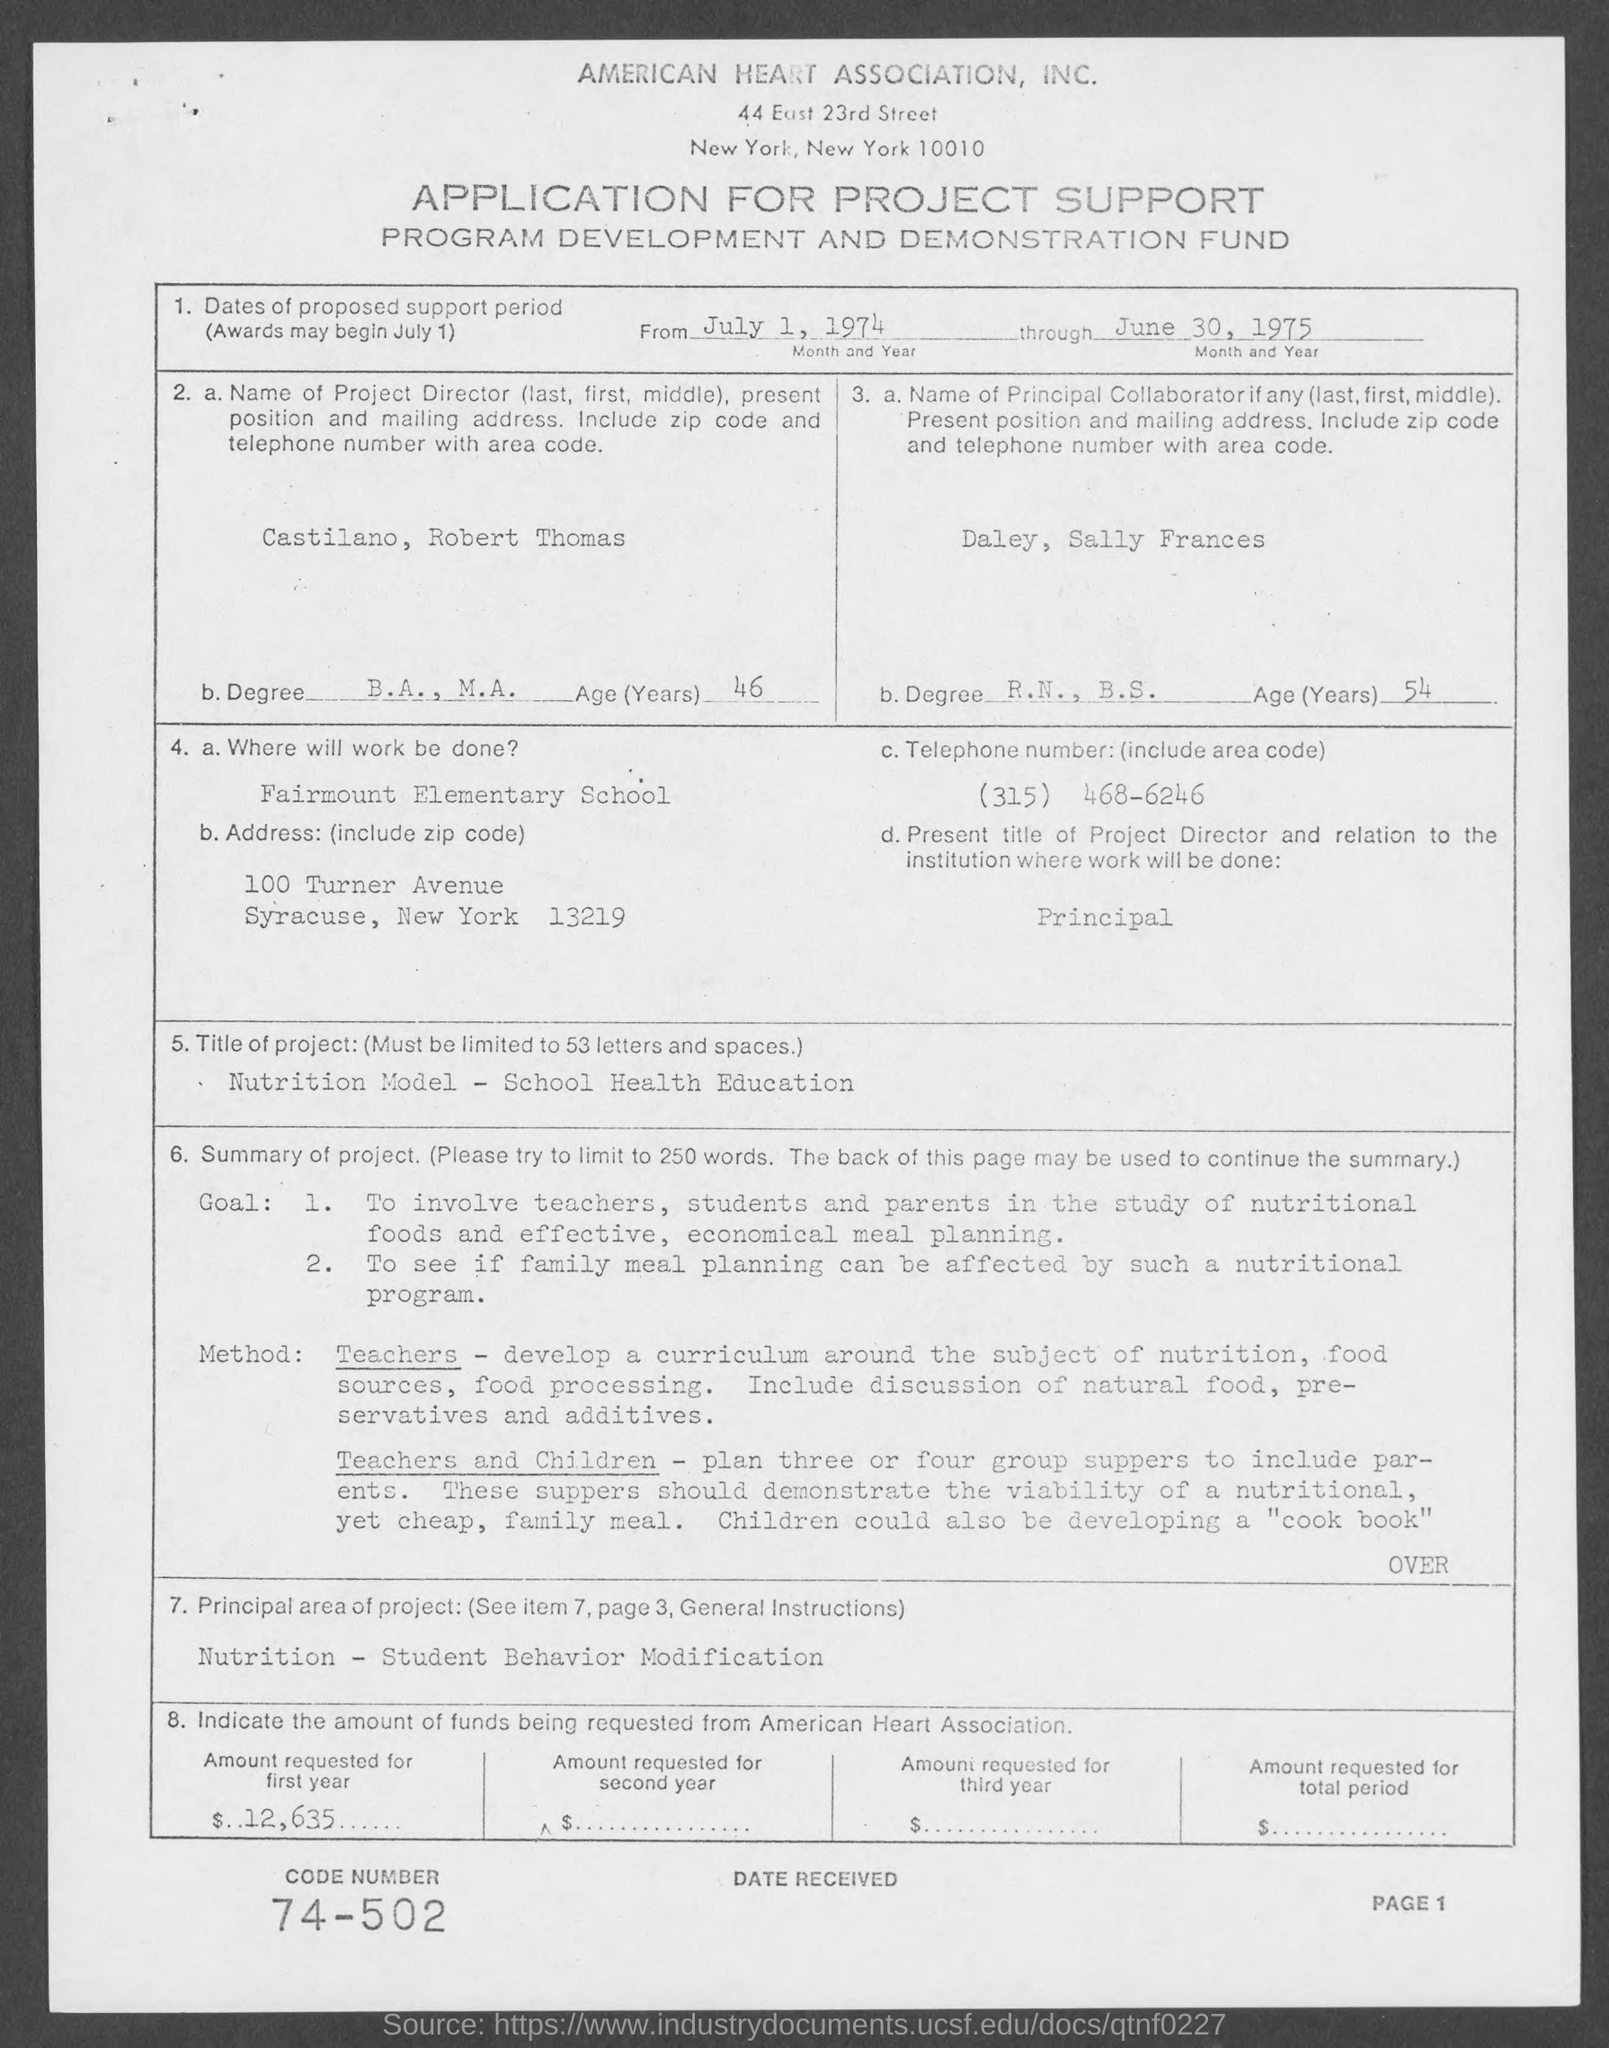What is the name of the association mentioned in the given page ?
Your answer should be very brief. American heart association. What is the age of the castilano , robert thomas mentioned in the given page ?
Provide a short and direct response. 46. What is the degree done by daley , sally frances mentioned in the given page ?
Your answer should be very brief. R.N., B.S. What is the age of Daley ,Sally Frances mentioned in the given page ?
Your answer should be compact. 54. What is the telephone number(include area code)mentioned in the given page ?
Offer a very short reply. (315) 468-6246. Where will work be done mentioned in the given page ?
Your answer should be compact. Fairmount Elementary school. What is the code number mentioned in the given page ?
Keep it short and to the point. 74-502. What are the dates of proposed support period as mentioned in the given page ?
Offer a terse response. From july 1, 1974 through june 30, 1975. What is the degree done by castilano, robert thomas as mentioned in the given page ?
Provide a short and direct response. B.A., M.A. 